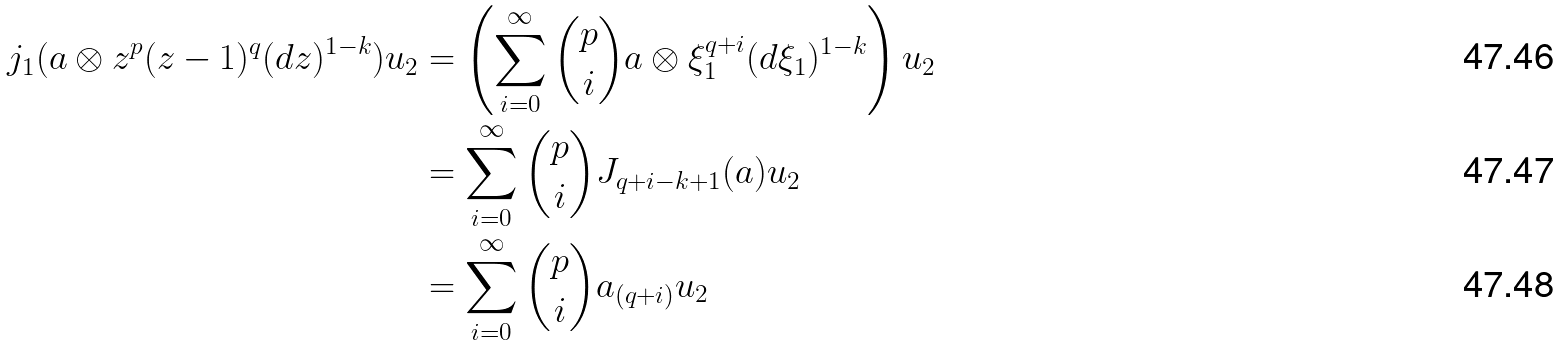<formula> <loc_0><loc_0><loc_500><loc_500>j _ { 1 } ( a \otimes z ^ { p } ( z - 1 ) ^ { q } ( d z ) ^ { 1 - k } ) u _ { 2 } & = \left ( \sum _ { i = 0 } ^ { \infty } \binom { p } { i } a \otimes \xi _ { 1 } ^ { q + i } ( d \xi _ { 1 } ) ^ { 1 - k } \right ) u _ { 2 } \\ & = \sum _ { i = 0 } ^ { \infty } \binom { p } { i } J _ { q + i - k + 1 } ( a ) u _ { 2 } \\ & = \sum _ { i = 0 } ^ { \infty } \binom { p } { i } a _ { ( q + i ) } u _ { 2 }</formula> 